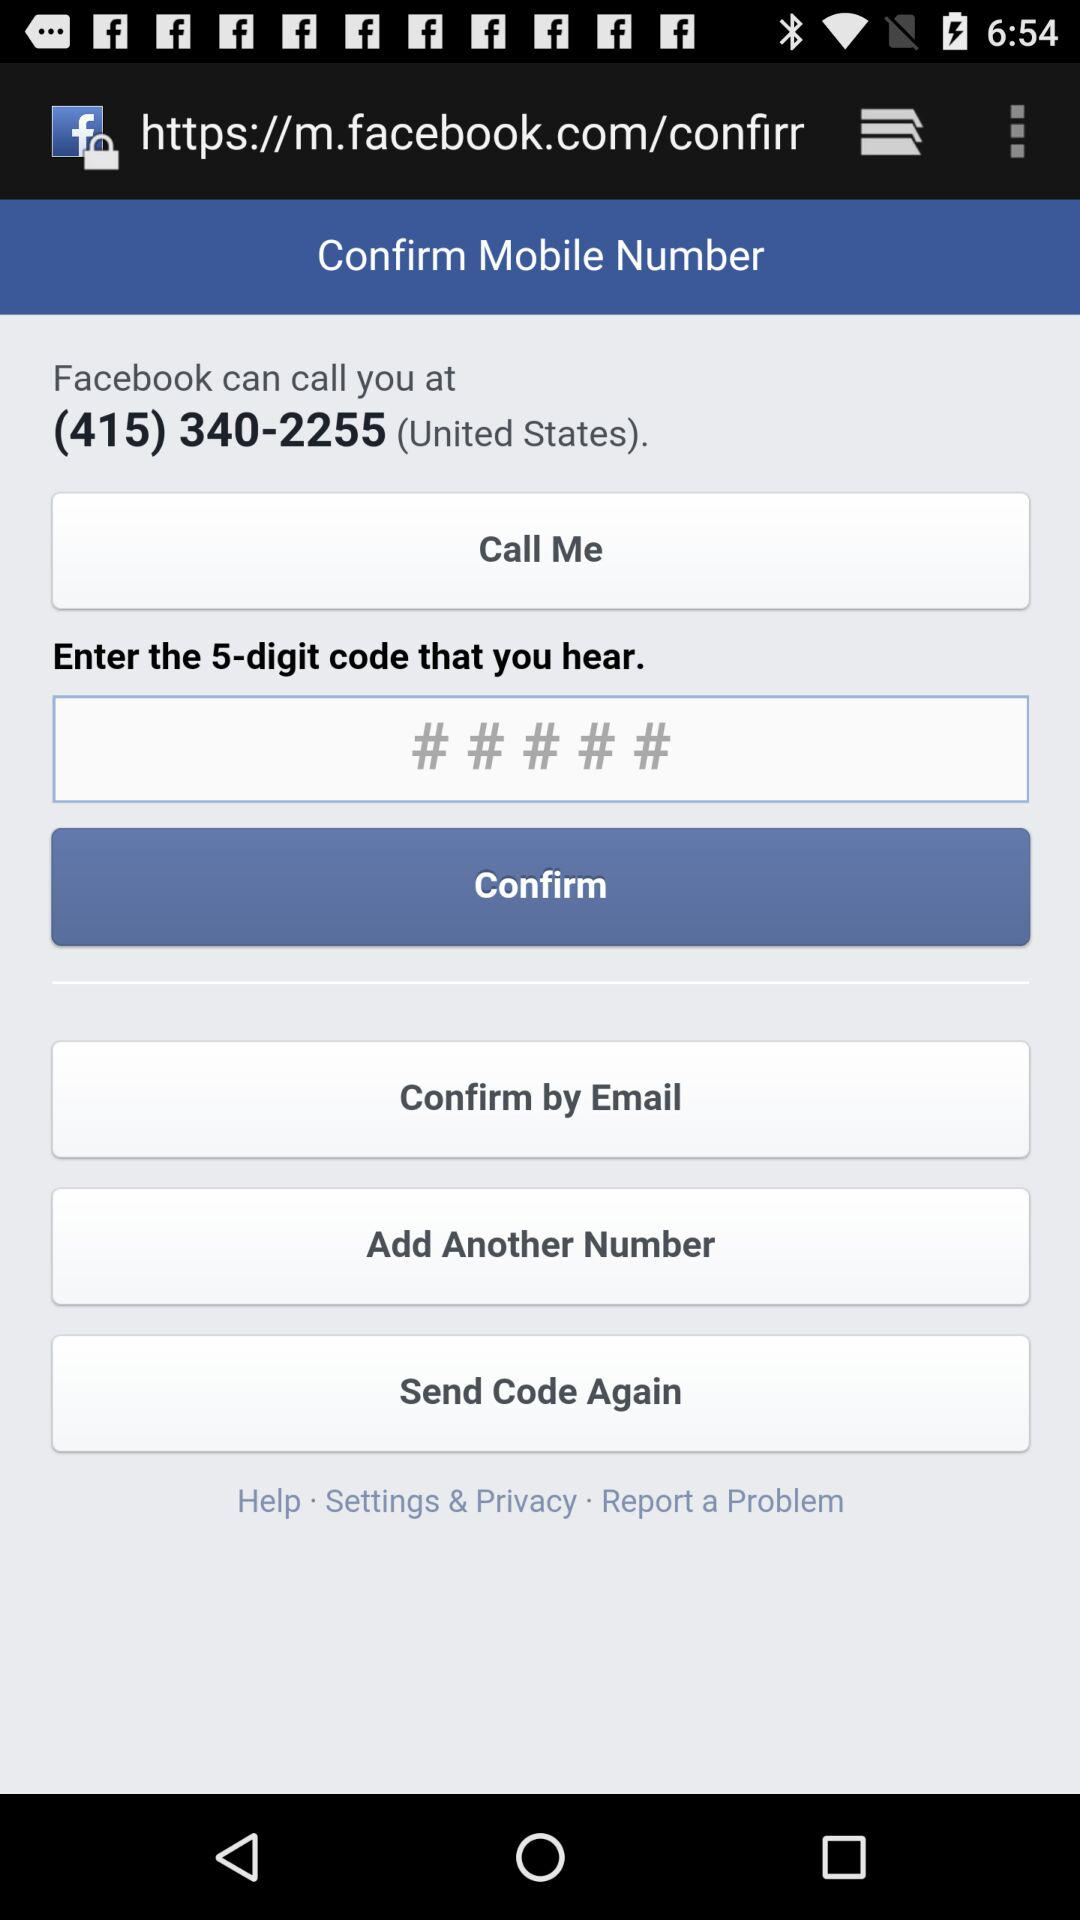What is the name of the application? The name of the application is "Facebook". 